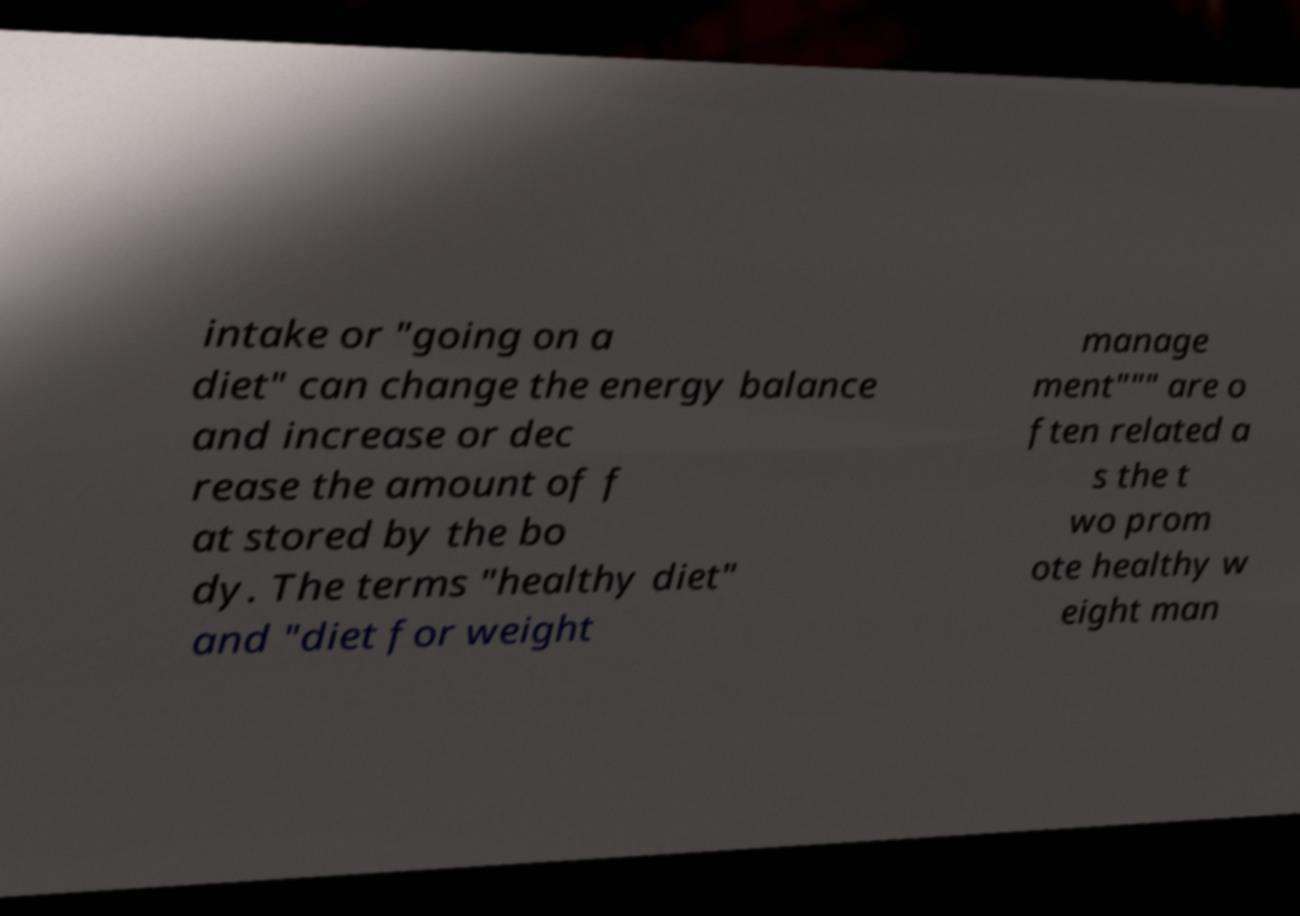Please read and relay the text visible in this image. What does it say? intake or "going on a diet" can change the energy balance and increase or dec rease the amount of f at stored by the bo dy. The terms "healthy diet" and "diet for weight manage ment""" are o ften related a s the t wo prom ote healthy w eight man 